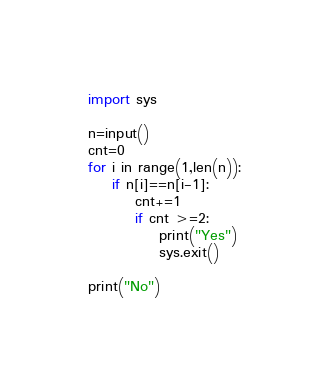<code> <loc_0><loc_0><loc_500><loc_500><_Python_>import sys

n=input()
cnt=0
for i in range(1,len(n)):
    if n[i]==n[i-1]:
        cnt+=1
        if cnt >=2:
            print("Yes")
            sys.exit()

print("No")</code> 